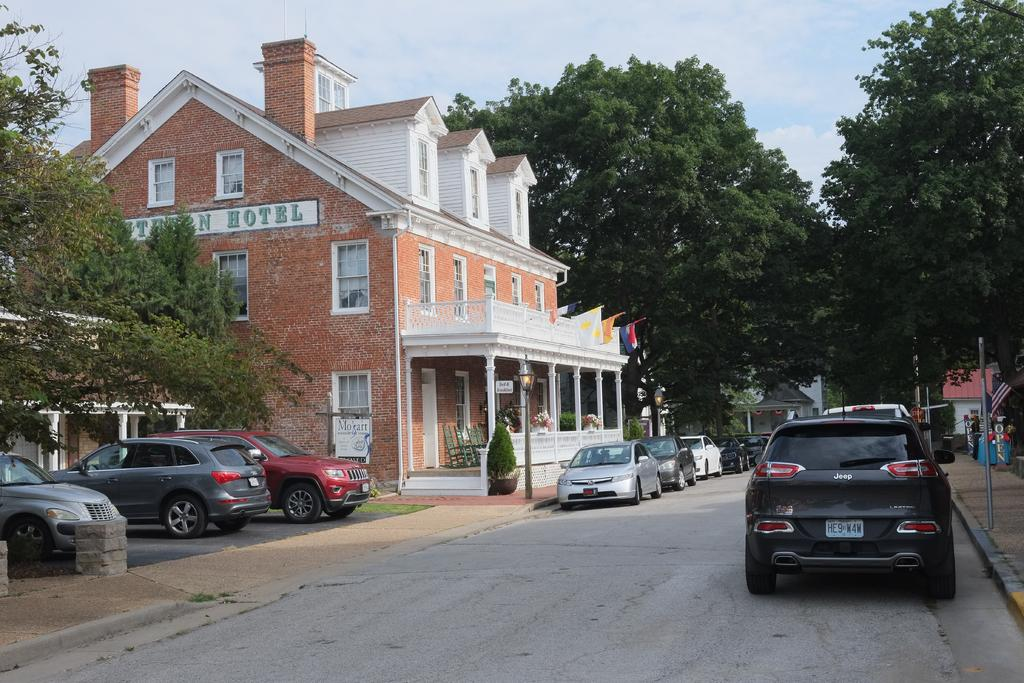What can be seen at the bottom of the image? There are vehicles on the road at the bottom of the image. What is visible in the background of the image? Trees, buildings, windows, light poles, chairs, flags, and a name board are visible in the background of the image. What is present in the sky in the background of the image? Clouds are visible in the sky in the background of the image. How many girls are walking down the street in the image? There are no girls or streets present in the image. What type of arm is visible on the vehicles in the image? There are no arms visible on the vehicles in the image; they are inanimate objects. 